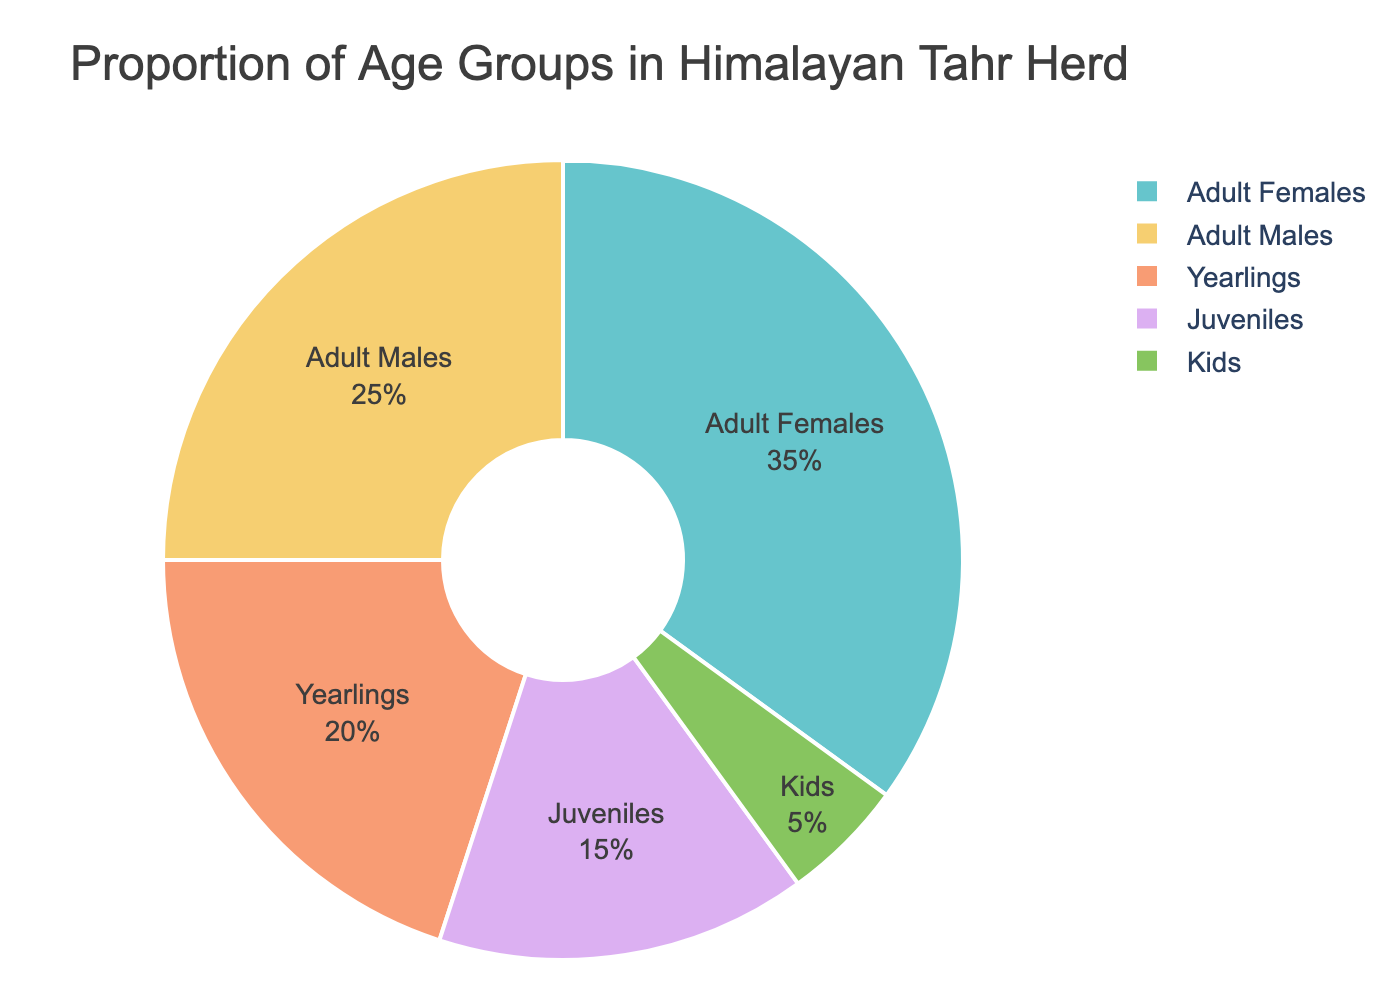What is the proportion of adult females in the Himalayan Tahr herd? From the pie chart, the segment labeled "Adult Females" represents 35% of the herd.
Answer: 35% Which age group has the smallest proportion of individuals in the herd? The pie chart indicates that the "Kids" segment, which accounts for 5%, is the smallest proportion.
Answer: Kids What is the total proportion of juveniles and yearlings in the herd? The pie chart labels "Juveniles" as 15% and "Yearlings" as 20%. Adding these proportions gives 15% + 20% = 35%.
Answer: 35% How does the proportion of adult males compare to the proportion of kids in the herd? The pie chart shows "Adult Males" at 25% and "Kids" at 5%. Thus, adult males have a greater proportion compared to kids.
Answer: Adult Males have greater proportion What is the difference in proportions between adult females and juveniles? From the chart, "Adult Females" compose 35% and "Juveniles" compose 15%. The difference is calculated as 35% - 15% = 20%.
Answer: 20% Which age group occupies the largest segment of the pie chart? The "Adult Females" segment, which is 35%, is the largest portion of the pie chart.
Answer: Adult Females Combine the proportions of yearlings, juveniles, and kids. What percentage of the herd do they constitute together? The proportions are given as 20% for yearlings, 15% for juveniles, and 5% for kids. Adding these together results in 20% + 15% + 5% = 40%.
Answer: 40% Is the proportion of yearlings greater than a quarter of the herd? The proportion for yearlings is 20%, which is less than 25% (a quarter of the herd).
Answer: No If adult males and females are combined, what percentage of the herd do they constitute? The chart shows "Adult Males" at 25% and "Adult Females" at 35%. Combining these gives 25% + 35% = 60%.
Answer: 60% Arrange the age groups in descending order based on their proportions. Reading from the pie chart: Adult Females (35%), Adult Males (25%), Yearlings (20%), Juveniles (15%), Kids (5%).
Answer: Adult Females, Adult Males, Yearlings, Juveniles, Kids 